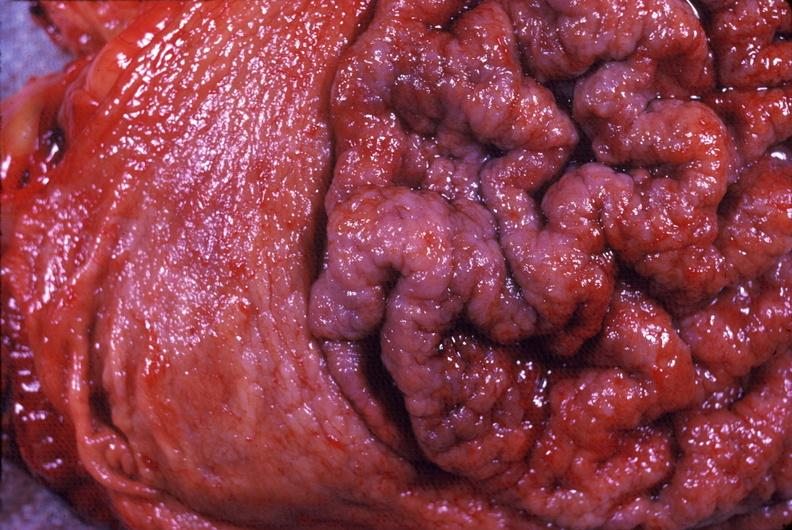s cytomegalovirus present?
Answer the question using a single word or phrase. No 